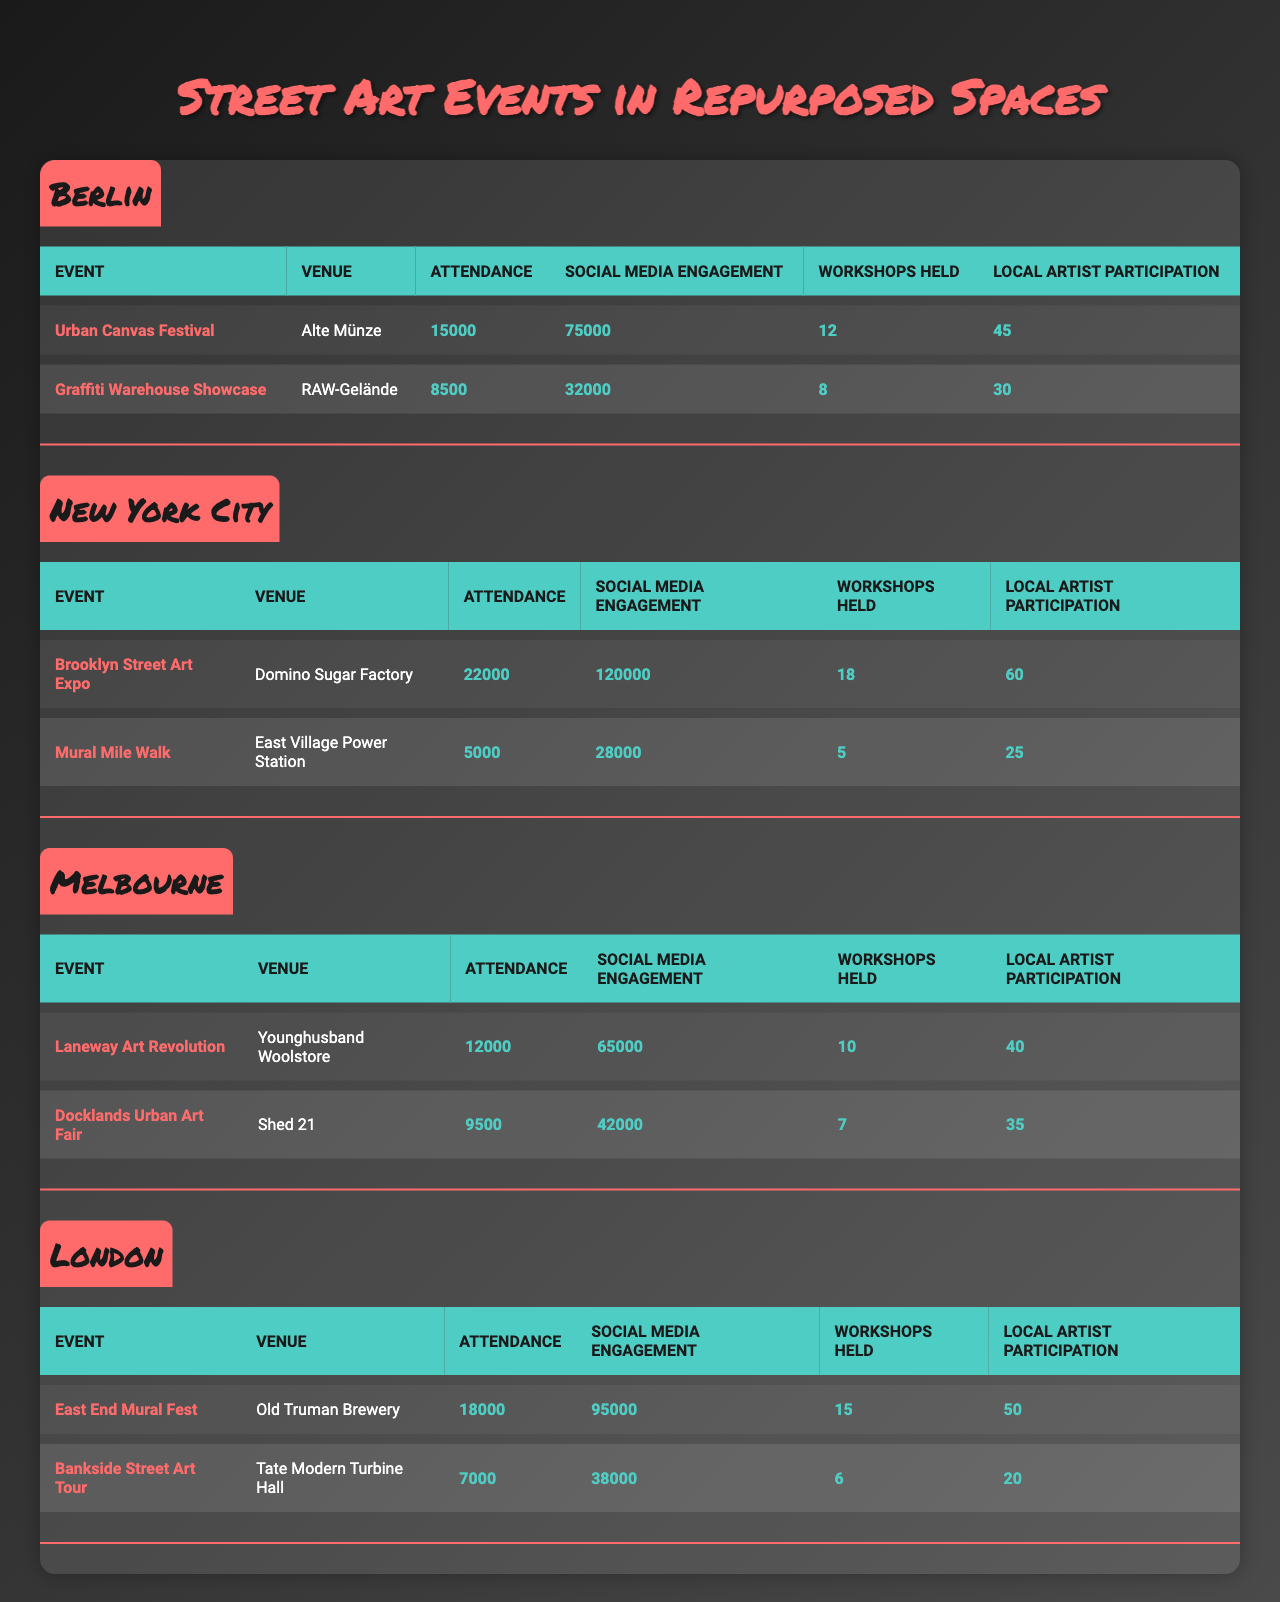what's the total attendance for the "Urban Canvas Festival" in Berlin? The attendance for the "Urban Canvas Festival" is listed as 15000.
Answer: 15000 how many workshops were held at the "Brooklyn Street Art Expo"? The "Brooklyn Street Art Expo" had 18 workshops held according to the table.
Answer: 18 which event in London had the highest attendance? The "East End Mural Fest" in London had the highest attendance at 18000, compared to the "Bankside Street Art Tour" which had 7000.
Answer: East End Mural Fest what is the total local artist participation across all events in Melbourne? The local artist participation in Melbourne is totaled by adding 40 (Laneway Art Revolution) and 35 (Docklands Urban Art Fair), which equals 75.
Answer: 75 true or false: the "Graffiti Warehouse Showcase" had more social media engagement than the "Docklands Urban Art Fair." The "Graffiti Warehouse Showcase" had 32000 social media engagements while the "Docklands Urban Art Fair" had 42000, making the statement false.
Answer: False what is the average attendance of events in New York City? The total attendance for the events in New York City is 22000 (Brooklyn Street Art Expo) + 5000 (Mural Mile Walk) = 27000. Dividing by the number of events (2) gives an average attendance of 13500.
Answer: 13500 which city had the lowest average social media engagement across its events? First, calculate the average social media engagement for each city: Berlin: (75000 + 32000) / 2 = 53500, New York City: (120000 + 28000) / 2 = 74000, Melbourne: (65000 + 42000) / 2 = 53500, London: (95000 + 38000) / 2 = 66500. Berlin and Melbourne both have the lowest average social media engagement at 53500.
Answer: Berlin and Melbourne how many more workshops were held at the "East End Mural Fest" compared to the "Mural Mile Walk"? The "East End Mural Fest" held 15 workshops while the "Mural Mile Walk" had 5. The difference is 15 - 5 = 10 workshops.
Answer: 10 which event had the highest local artist participation, and how many artists participated? The "Brooklyn Street Art Expo" had the highest local artist participation with 60 artists.
Answer: Brooklyn Street Art Expo, 60 is the total attendance for events in Berlin greater than the total attendance for events in London? Total attendance in Berlin is 15000 + 8500 = 23500, and in London it is 18000 + 7000 = 25000. Since 23500 is less than 25000, the answer is no.
Answer: No 